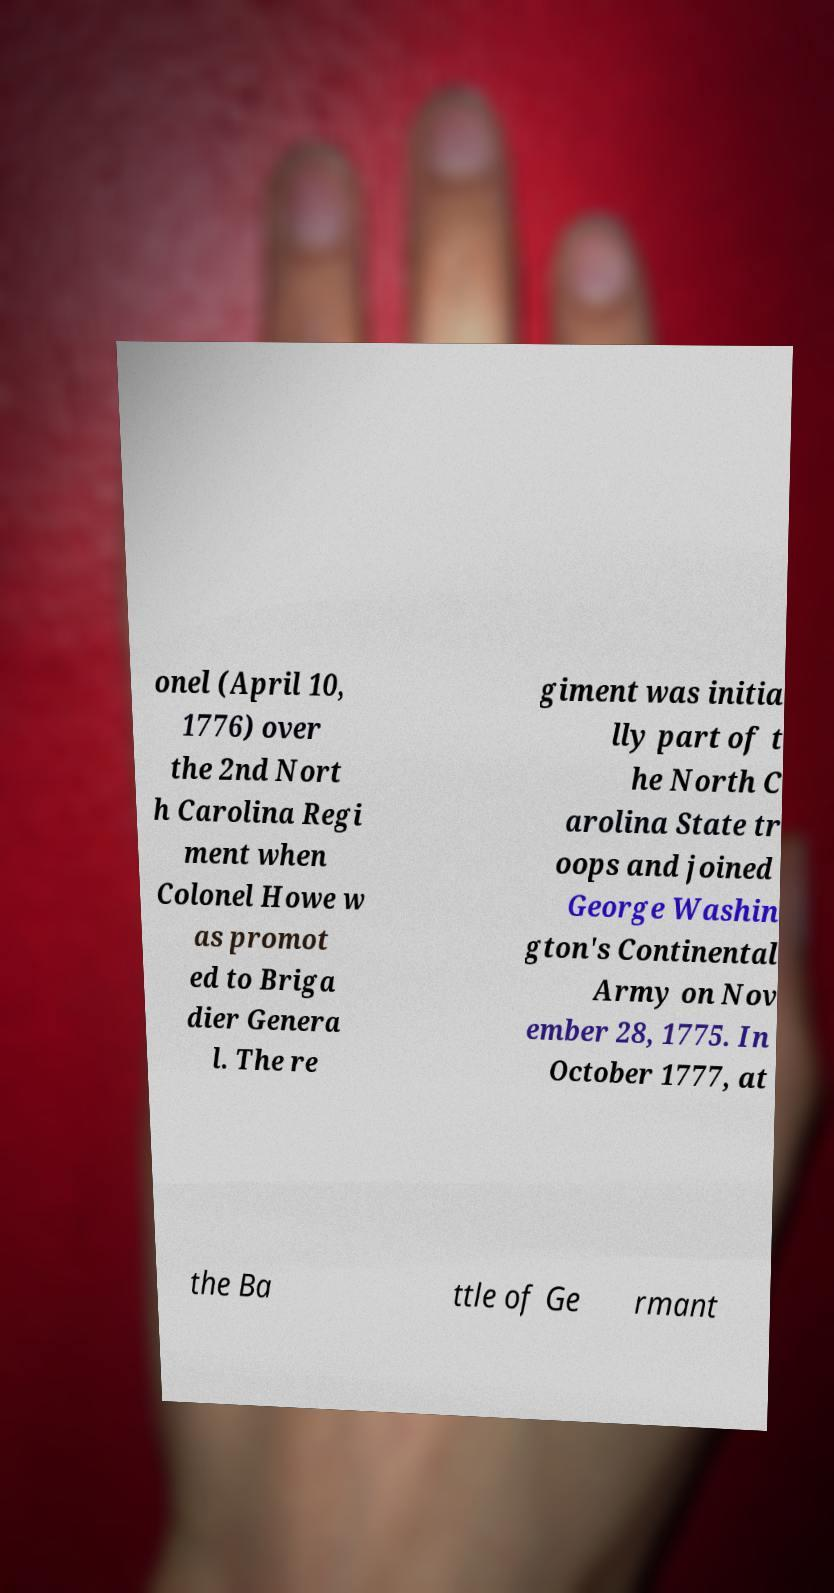Can you read and provide the text displayed in the image?This photo seems to have some interesting text. Can you extract and type it out for me? onel (April 10, 1776) over the 2nd Nort h Carolina Regi ment when Colonel Howe w as promot ed to Briga dier Genera l. The re giment was initia lly part of t he North C arolina State tr oops and joined George Washin gton's Continental Army on Nov ember 28, 1775. In October 1777, at the Ba ttle of Ge rmant 